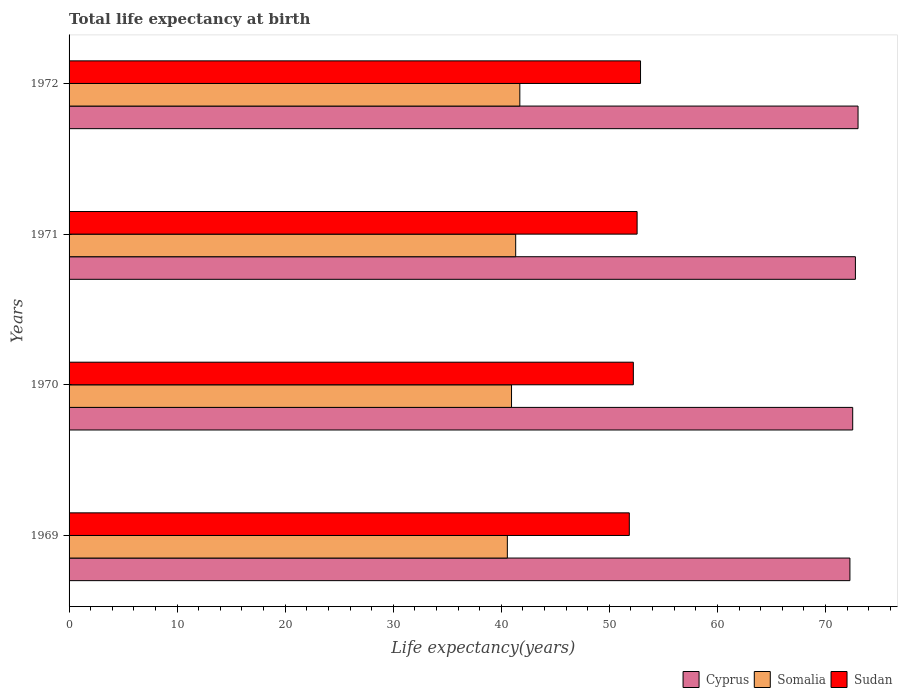How many different coloured bars are there?
Give a very brief answer. 3. Are the number of bars on each tick of the Y-axis equal?
Provide a short and direct response. Yes. How many bars are there on the 1st tick from the top?
Your answer should be very brief. 3. How many bars are there on the 4th tick from the bottom?
Your answer should be very brief. 3. In how many cases, is the number of bars for a given year not equal to the number of legend labels?
Keep it short and to the point. 0. What is the life expectancy at birth in in Somalia in 1970?
Provide a short and direct response. 40.95. Across all years, what is the maximum life expectancy at birth in in Somalia?
Give a very brief answer. 41.72. Across all years, what is the minimum life expectancy at birth in in Somalia?
Offer a terse response. 40.56. In which year was the life expectancy at birth in in Somalia minimum?
Your response must be concise. 1969. What is the total life expectancy at birth in in Sudan in the graph?
Your response must be concise. 209.53. What is the difference between the life expectancy at birth in in Sudan in 1969 and that in 1971?
Make the answer very short. -0.72. What is the difference between the life expectancy at birth in in Somalia in 1970 and the life expectancy at birth in in Sudan in 1972?
Ensure brevity in your answer.  -11.94. What is the average life expectancy at birth in in Sudan per year?
Provide a succinct answer. 52.38. In the year 1971, what is the difference between the life expectancy at birth in in Sudan and life expectancy at birth in in Cyprus?
Provide a succinct answer. -20.2. In how many years, is the life expectancy at birth in in Sudan greater than 52 years?
Provide a short and direct response. 3. What is the ratio of the life expectancy at birth in in Somalia in 1971 to that in 1972?
Make the answer very short. 0.99. Is the life expectancy at birth in in Somalia in 1970 less than that in 1971?
Your answer should be compact. Yes. What is the difference between the highest and the second highest life expectancy at birth in in Somalia?
Your response must be concise. 0.38. What is the difference between the highest and the lowest life expectancy at birth in in Sudan?
Give a very brief answer. 1.04. In how many years, is the life expectancy at birth in in Somalia greater than the average life expectancy at birth in in Somalia taken over all years?
Your response must be concise. 2. What does the 1st bar from the top in 1971 represents?
Your response must be concise. Sudan. What does the 3rd bar from the bottom in 1972 represents?
Make the answer very short. Sudan. Is it the case that in every year, the sum of the life expectancy at birth in in Somalia and life expectancy at birth in in Sudan is greater than the life expectancy at birth in in Cyprus?
Provide a short and direct response. Yes. What is the difference between two consecutive major ticks on the X-axis?
Make the answer very short. 10. Are the values on the major ticks of X-axis written in scientific E-notation?
Your answer should be compact. No. Does the graph contain grids?
Offer a very short reply. No. Where does the legend appear in the graph?
Offer a very short reply. Bottom right. How are the legend labels stacked?
Provide a succinct answer. Horizontal. What is the title of the graph?
Ensure brevity in your answer.  Total life expectancy at birth. Does "Northern Mariana Islands" appear as one of the legend labels in the graph?
Your response must be concise. No. What is the label or title of the X-axis?
Your answer should be compact. Life expectancy(years). What is the label or title of the Y-axis?
Provide a succinct answer. Years. What is the Life expectancy(years) of Cyprus in 1969?
Your answer should be very brief. 72.27. What is the Life expectancy(years) in Somalia in 1969?
Your answer should be compact. 40.56. What is the Life expectancy(years) of Sudan in 1969?
Offer a terse response. 51.85. What is the Life expectancy(years) of Cyprus in 1970?
Your answer should be compact. 72.52. What is the Life expectancy(years) of Somalia in 1970?
Offer a terse response. 40.95. What is the Life expectancy(years) in Sudan in 1970?
Your response must be concise. 52.22. What is the Life expectancy(years) in Cyprus in 1971?
Offer a terse response. 72.77. What is the Life expectancy(years) of Somalia in 1971?
Keep it short and to the point. 41.33. What is the Life expectancy(years) in Sudan in 1971?
Keep it short and to the point. 52.57. What is the Life expectancy(years) of Cyprus in 1972?
Ensure brevity in your answer.  73.02. What is the Life expectancy(years) in Somalia in 1972?
Offer a very short reply. 41.72. What is the Life expectancy(years) in Sudan in 1972?
Keep it short and to the point. 52.89. Across all years, what is the maximum Life expectancy(years) in Cyprus?
Provide a short and direct response. 73.02. Across all years, what is the maximum Life expectancy(years) in Somalia?
Ensure brevity in your answer.  41.72. Across all years, what is the maximum Life expectancy(years) of Sudan?
Your answer should be very brief. 52.89. Across all years, what is the minimum Life expectancy(years) in Cyprus?
Offer a very short reply. 72.27. Across all years, what is the minimum Life expectancy(years) of Somalia?
Offer a terse response. 40.56. Across all years, what is the minimum Life expectancy(years) of Sudan?
Offer a very short reply. 51.85. What is the total Life expectancy(years) in Cyprus in the graph?
Your answer should be very brief. 290.58. What is the total Life expectancy(years) of Somalia in the graph?
Provide a succinct answer. 164.56. What is the total Life expectancy(years) in Sudan in the graph?
Keep it short and to the point. 209.53. What is the difference between the Life expectancy(years) in Cyprus in 1969 and that in 1970?
Ensure brevity in your answer.  -0.26. What is the difference between the Life expectancy(years) of Somalia in 1969 and that in 1970?
Your answer should be very brief. -0.39. What is the difference between the Life expectancy(years) of Sudan in 1969 and that in 1970?
Offer a very short reply. -0.37. What is the difference between the Life expectancy(years) of Cyprus in 1969 and that in 1971?
Your answer should be very brief. -0.51. What is the difference between the Life expectancy(years) in Somalia in 1969 and that in 1971?
Offer a terse response. -0.77. What is the difference between the Life expectancy(years) of Sudan in 1969 and that in 1971?
Offer a terse response. -0.72. What is the difference between the Life expectancy(years) of Cyprus in 1969 and that in 1972?
Your answer should be compact. -0.75. What is the difference between the Life expectancy(years) of Somalia in 1969 and that in 1972?
Provide a succinct answer. -1.16. What is the difference between the Life expectancy(years) of Sudan in 1969 and that in 1972?
Provide a short and direct response. -1.04. What is the difference between the Life expectancy(years) of Cyprus in 1970 and that in 1971?
Make the answer very short. -0.25. What is the difference between the Life expectancy(years) in Somalia in 1970 and that in 1971?
Provide a short and direct response. -0.39. What is the difference between the Life expectancy(years) of Sudan in 1970 and that in 1971?
Your answer should be compact. -0.35. What is the difference between the Life expectancy(years) of Cyprus in 1970 and that in 1972?
Provide a succinct answer. -0.49. What is the difference between the Life expectancy(years) in Somalia in 1970 and that in 1972?
Your answer should be compact. -0.77. What is the difference between the Life expectancy(years) of Sudan in 1970 and that in 1972?
Provide a succinct answer. -0.67. What is the difference between the Life expectancy(years) of Cyprus in 1971 and that in 1972?
Your response must be concise. -0.24. What is the difference between the Life expectancy(years) in Somalia in 1971 and that in 1972?
Provide a succinct answer. -0.38. What is the difference between the Life expectancy(years) in Sudan in 1971 and that in 1972?
Offer a terse response. -0.32. What is the difference between the Life expectancy(years) in Cyprus in 1969 and the Life expectancy(years) in Somalia in 1970?
Ensure brevity in your answer.  31.32. What is the difference between the Life expectancy(years) in Cyprus in 1969 and the Life expectancy(years) in Sudan in 1970?
Offer a very short reply. 20.04. What is the difference between the Life expectancy(years) of Somalia in 1969 and the Life expectancy(years) of Sudan in 1970?
Offer a very short reply. -11.66. What is the difference between the Life expectancy(years) in Cyprus in 1969 and the Life expectancy(years) in Somalia in 1971?
Give a very brief answer. 30.93. What is the difference between the Life expectancy(years) in Cyprus in 1969 and the Life expectancy(years) in Sudan in 1971?
Your answer should be very brief. 19.7. What is the difference between the Life expectancy(years) of Somalia in 1969 and the Life expectancy(years) of Sudan in 1971?
Provide a short and direct response. -12.01. What is the difference between the Life expectancy(years) in Cyprus in 1969 and the Life expectancy(years) in Somalia in 1972?
Offer a very short reply. 30.55. What is the difference between the Life expectancy(years) in Cyprus in 1969 and the Life expectancy(years) in Sudan in 1972?
Make the answer very short. 19.38. What is the difference between the Life expectancy(years) in Somalia in 1969 and the Life expectancy(years) in Sudan in 1972?
Provide a succinct answer. -12.33. What is the difference between the Life expectancy(years) in Cyprus in 1970 and the Life expectancy(years) in Somalia in 1971?
Make the answer very short. 31.19. What is the difference between the Life expectancy(years) in Cyprus in 1970 and the Life expectancy(years) in Sudan in 1971?
Provide a succinct answer. 19.95. What is the difference between the Life expectancy(years) of Somalia in 1970 and the Life expectancy(years) of Sudan in 1971?
Your answer should be compact. -11.62. What is the difference between the Life expectancy(years) in Cyprus in 1970 and the Life expectancy(years) in Somalia in 1972?
Give a very brief answer. 30.81. What is the difference between the Life expectancy(years) of Cyprus in 1970 and the Life expectancy(years) of Sudan in 1972?
Provide a succinct answer. 19.64. What is the difference between the Life expectancy(years) of Somalia in 1970 and the Life expectancy(years) of Sudan in 1972?
Offer a very short reply. -11.94. What is the difference between the Life expectancy(years) in Cyprus in 1971 and the Life expectancy(years) in Somalia in 1972?
Provide a succinct answer. 31.06. What is the difference between the Life expectancy(years) in Cyprus in 1971 and the Life expectancy(years) in Sudan in 1972?
Your response must be concise. 19.89. What is the difference between the Life expectancy(years) in Somalia in 1971 and the Life expectancy(years) in Sudan in 1972?
Give a very brief answer. -11.55. What is the average Life expectancy(years) of Cyprus per year?
Provide a short and direct response. 72.64. What is the average Life expectancy(years) in Somalia per year?
Make the answer very short. 41.14. What is the average Life expectancy(years) in Sudan per year?
Offer a very short reply. 52.38. In the year 1969, what is the difference between the Life expectancy(years) in Cyprus and Life expectancy(years) in Somalia?
Provide a short and direct response. 31.71. In the year 1969, what is the difference between the Life expectancy(years) in Cyprus and Life expectancy(years) in Sudan?
Provide a succinct answer. 20.42. In the year 1969, what is the difference between the Life expectancy(years) of Somalia and Life expectancy(years) of Sudan?
Your response must be concise. -11.29. In the year 1970, what is the difference between the Life expectancy(years) of Cyprus and Life expectancy(years) of Somalia?
Make the answer very short. 31.57. In the year 1970, what is the difference between the Life expectancy(years) in Cyprus and Life expectancy(years) in Sudan?
Ensure brevity in your answer.  20.3. In the year 1970, what is the difference between the Life expectancy(years) in Somalia and Life expectancy(years) in Sudan?
Ensure brevity in your answer.  -11.27. In the year 1971, what is the difference between the Life expectancy(years) in Cyprus and Life expectancy(years) in Somalia?
Offer a very short reply. 31.44. In the year 1971, what is the difference between the Life expectancy(years) in Cyprus and Life expectancy(years) in Sudan?
Provide a succinct answer. 20.2. In the year 1971, what is the difference between the Life expectancy(years) of Somalia and Life expectancy(years) of Sudan?
Your answer should be compact. -11.24. In the year 1972, what is the difference between the Life expectancy(years) in Cyprus and Life expectancy(years) in Somalia?
Keep it short and to the point. 31.3. In the year 1972, what is the difference between the Life expectancy(years) of Cyprus and Life expectancy(years) of Sudan?
Your answer should be compact. 20.13. In the year 1972, what is the difference between the Life expectancy(years) in Somalia and Life expectancy(years) in Sudan?
Provide a succinct answer. -11.17. What is the ratio of the Life expectancy(years) of Cyprus in 1969 to that in 1970?
Your answer should be very brief. 1. What is the ratio of the Life expectancy(years) in Somalia in 1969 to that in 1970?
Offer a very short reply. 0.99. What is the ratio of the Life expectancy(years) in Cyprus in 1969 to that in 1971?
Offer a very short reply. 0.99. What is the ratio of the Life expectancy(years) of Somalia in 1969 to that in 1971?
Make the answer very short. 0.98. What is the ratio of the Life expectancy(years) in Sudan in 1969 to that in 1971?
Make the answer very short. 0.99. What is the ratio of the Life expectancy(years) in Cyprus in 1969 to that in 1972?
Make the answer very short. 0.99. What is the ratio of the Life expectancy(years) in Somalia in 1969 to that in 1972?
Your answer should be very brief. 0.97. What is the ratio of the Life expectancy(years) of Sudan in 1969 to that in 1972?
Your answer should be compact. 0.98. What is the ratio of the Life expectancy(years) in Cyprus in 1970 to that in 1972?
Make the answer very short. 0.99. What is the ratio of the Life expectancy(years) in Somalia in 1970 to that in 1972?
Provide a short and direct response. 0.98. What is the ratio of the Life expectancy(years) in Sudan in 1970 to that in 1972?
Your answer should be compact. 0.99. What is the ratio of the Life expectancy(years) of Cyprus in 1971 to that in 1972?
Provide a short and direct response. 1. What is the difference between the highest and the second highest Life expectancy(years) of Cyprus?
Provide a succinct answer. 0.24. What is the difference between the highest and the second highest Life expectancy(years) in Somalia?
Your answer should be compact. 0.38. What is the difference between the highest and the second highest Life expectancy(years) in Sudan?
Keep it short and to the point. 0.32. What is the difference between the highest and the lowest Life expectancy(years) in Cyprus?
Ensure brevity in your answer.  0.75. What is the difference between the highest and the lowest Life expectancy(years) in Somalia?
Keep it short and to the point. 1.16. What is the difference between the highest and the lowest Life expectancy(years) in Sudan?
Keep it short and to the point. 1.04. 